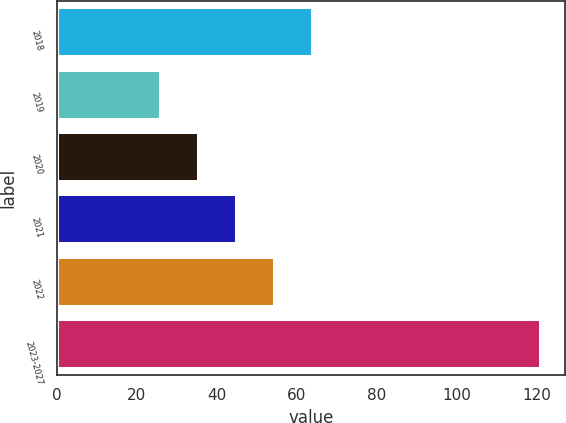Convert chart. <chart><loc_0><loc_0><loc_500><loc_500><bar_chart><fcel>2018<fcel>2019<fcel>2020<fcel>2021<fcel>2022<fcel>2023-2027<nl><fcel>64<fcel>26<fcel>35.5<fcel>45<fcel>54.5<fcel>121<nl></chart> 